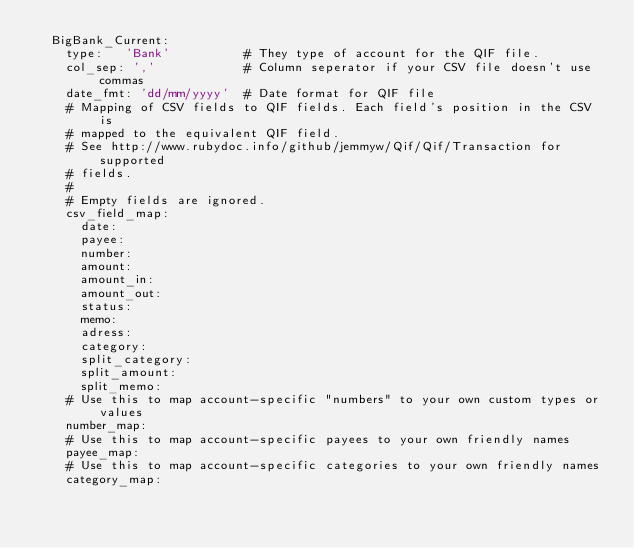Convert code to text. <code><loc_0><loc_0><loc_500><loc_500><_YAML_>  BigBank_Current:
    type:   'Bank'          # They type of account for the QIF file.
    col_sep: ','            # Column seperator if your CSV file doesn't use commas
    date_fmt: 'dd/mm/yyyy'  # Date format for QIF file
    # Mapping of CSV fields to QIF fields. Each field's position in the CSV is
    # mapped to the equivalent QIF field.
    # See http://www.rubydoc.info/github/jemmyw/Qif/Qif/Transaction for supported
    # fields.
    #
    # Empty fields are ignored.
    csv_field_map:
      date:
      payee:
      number:
      amount:
      amount_in:
      amount_out:
      status:
      memo:
      adress:
      category:
      split_category:
      split_amount:
      split_memo:
    # Use this to map account-specific "numbers" to your own custom types or values
    number_map:
    # Use this to map account-specific payees to your own friendly names
    payee_map:
    # Use this to map account-specific categories to your own friendly names
    category_map:
</code> 